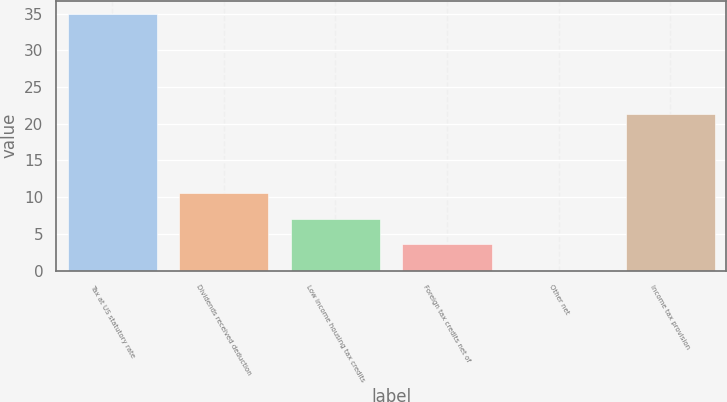Convert chart. <chart><loc_0><loc_0><loc_500><loc_500><bar_chart><fcel>Tax at US statutory rate<fcel>Dividends received deduction<fcel>Low income housing tax credits<fcel>Foreign tax credits net of<fcel>Other net<fcel>Income tax provision<nl><fcel>35<fcel>10.57<fcel>7.08<fcel>3.59<fcel>0.1<fcel>21.3<nl></chart> 